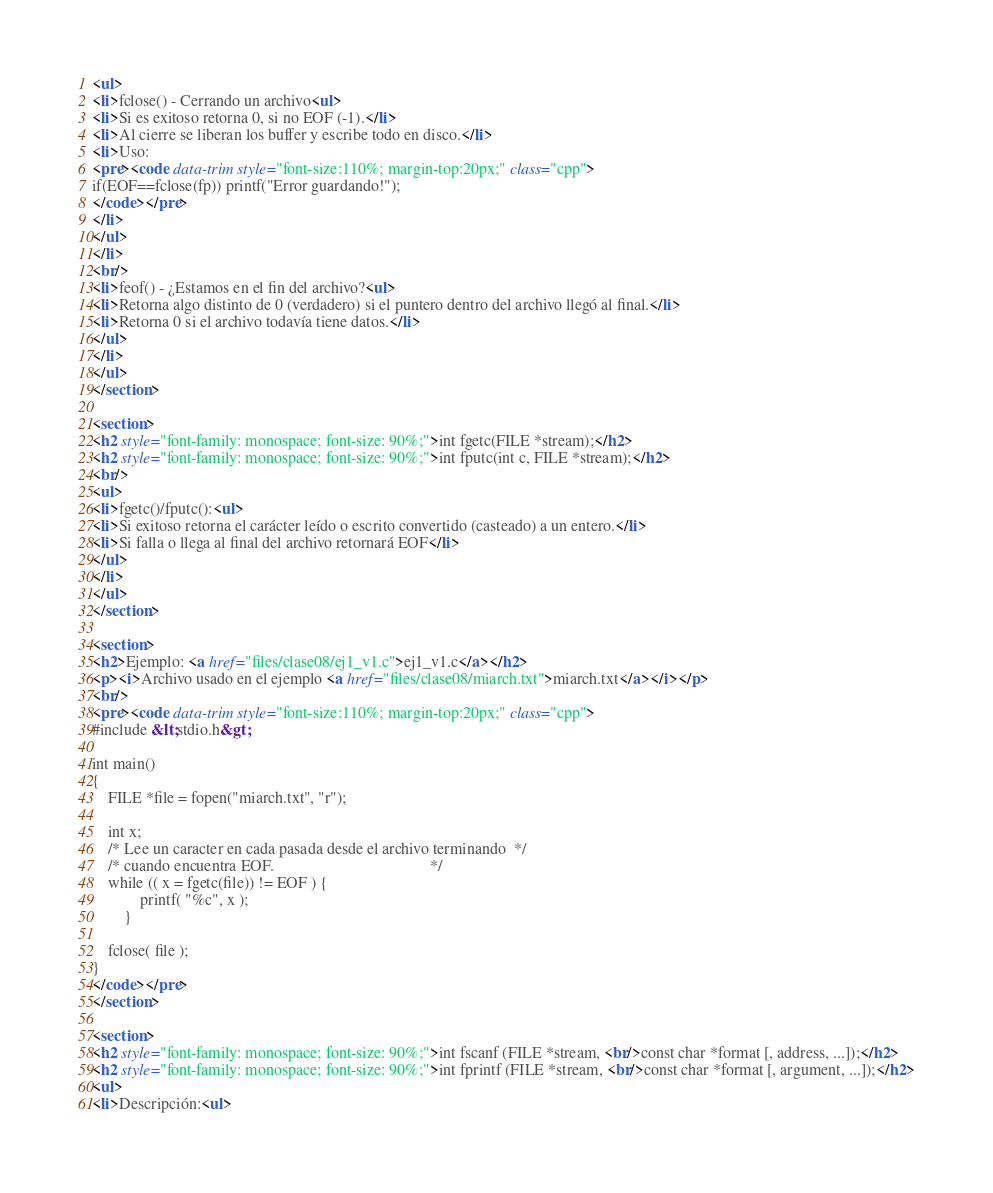<code> <loc_0><loc_0><loc_500><loc_500><_HTML_><ul>
<li>fclose() - Cerrando un archivo<ul>
<li>Si es exitoso retorna 0, si no EOF (-1).</li>
<li>Al cierre se liberan los buffer y escribe todo en disco.</li>
<li>Uso:
<pre><code data-trim style="font-size:110%; margin-top:20px;" class="cpp">
if(EOF==fclose(fp)) printf("Error guardando!");
</code></pre>
</li>
</ul>
</li>
<br/>
<li>feof() - ¿Estamos en el fin del archivo?<ul>
<li>Retorna algo distinto de 0 (verdadero) si el puntero dentro del archivo llegó al final.</li>
<li>Retorna 0 si el archivo todavía tiene datos.</li>
</ul>
</li>
</ul>
</section>

<section>
<h2 style="font-family: monospace; font-size: 90%;">int fgetc(FILE *stream);</h2>
<h2 style="font-family: monospace; font-size: 90%;">int fputc(int c, FILE *stream);</h2>
<br/>
<ul>
<li>fgetc()/fputc():<ul>
<li>Si exitoso retorna el carácter leído o escrito convertido (casteado) a un entero.</li>
<li>Si falla o llega al final del archivo retornará EOF</li>
</ul>
</li>
</ul>
</section>

<section>
<h2>Ejemplo: <a href="files/clase08/ej1_v1.c">ej1_v1.c</a></h2>
<p><i>Archivo usado en el ejemplo <a href="files/clase08/miarch.txt">miarch.txt</a></i></p>
<br/>
<pre><code data-trim style="font-size:110%; margin-top:20px;" class="cpp">
#include &lt;stdio.h&gt;

int main()
{
    FILE *file = fopen("miarch.txt", "r");

    int x;
    /* Lee un caracter en cada pasada desde el archivo terminando  */
    /* cuando encuentra EOF.                                       */
    while (( x = fgetc(file)) != EOF ) {
            printf( "%c", x );
        }

    fclose( file );
}
</code></pre>
</section>

<section>
<h2 style="font-family: monospace; font-size: 90%;">int fscanf (FILE *stream, <br/>const char *format [, address, ...]);</h2>
<h2 style="font-family: monospace; font-size: 90%;">int fprintf (FILE *stream, <br/>const char *format [, argument, ...]);</h2>
<ul>
<li>Descripción:<ul></code> 